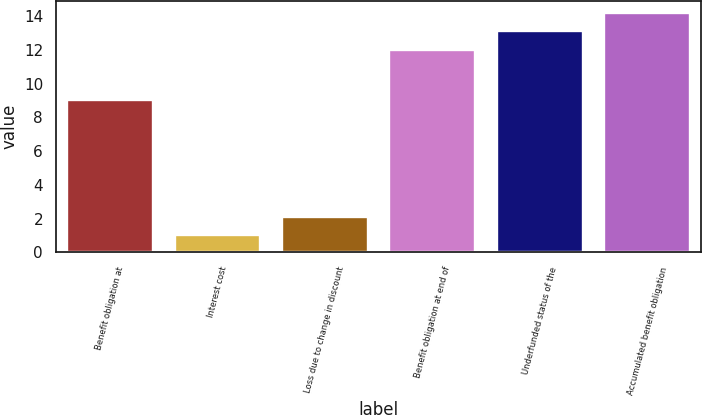<chart> <loc_0><loc_0><loc_500><loc_500><bar_chart><fcel>Benefit obligation at<fcel>Interest cost<fcel>Loss due to change in discount<fcel>Benefit obligation at end of<fcel>Underfunded status of the<fcel>Accumulated benefit obligation<nl><fcel>9<fcel>1<fcel>2.1<fcel>12<fcel>13.1<fcel>14.2<nl></chart> 